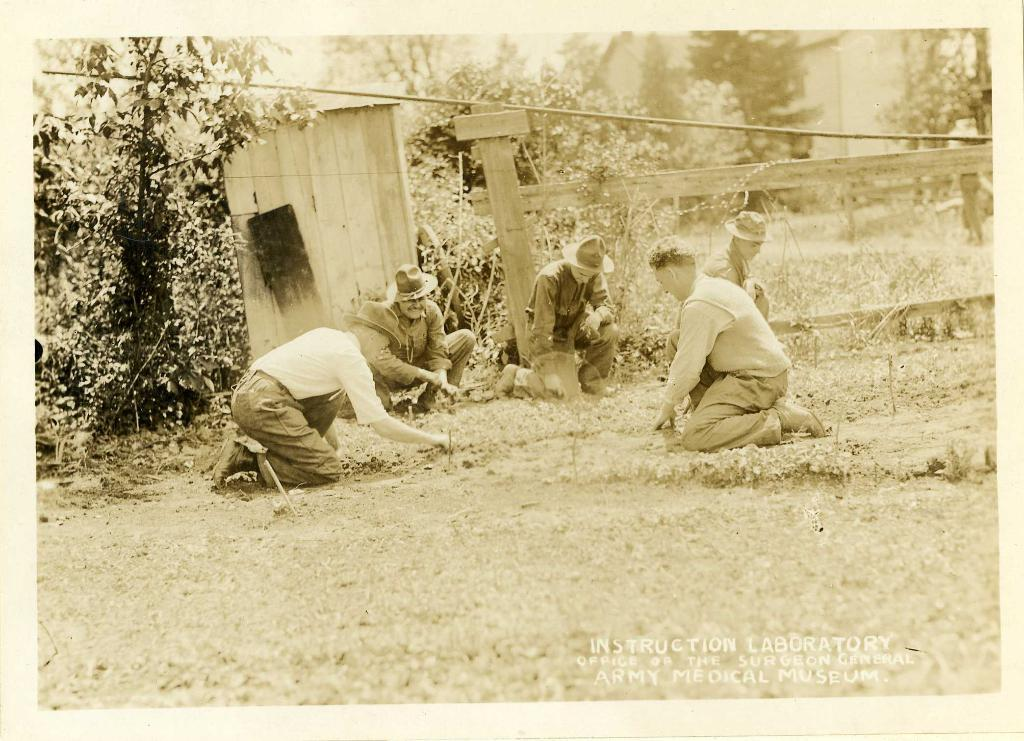What is the main subject of the image? The main subject of the image is a photograph. What can be seen in the photograph? The photograph contains trees, people, a wooden pole, a wire, a house, grass, soil, and a wooden object. Where is the text located in the image? The text is at the bottom of the image. How many fowl are visible in the image? There are no fowl present in the image. What type of trail can be seen in the image? There is no trail visible in the image. 